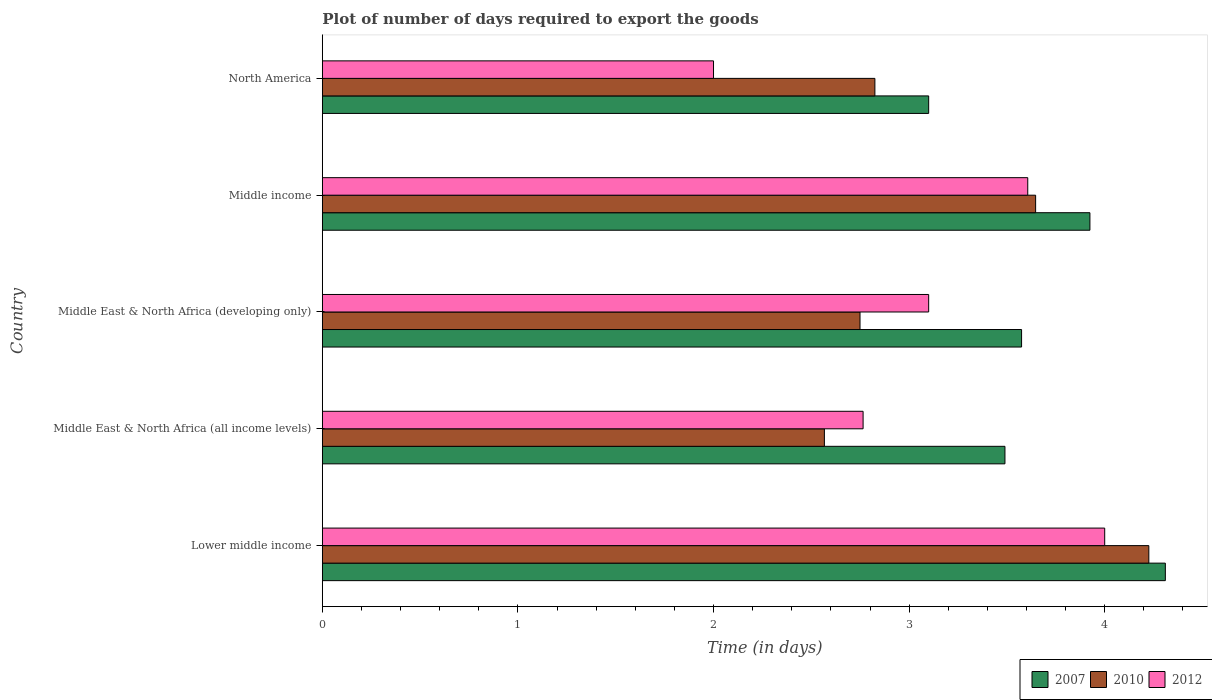How many groups of bars are there?
Keep it short and to the point. 5. Are the number of bars on each tick of the Y-axis equal?
Your answer should be compact. Yes. How many bars are there on the 4th tick from the top?
Provide a short and direct response. 3. How many bars are there on the 5th tick from the bottom?
Provide a succinct answer. 3. What is the label of the 5th group of bars from the top?
Your answer should be very brief. Lower middle income. In how many cases, is the number of bars for a given country not equal to the number of legend labels?
Provide a short and direct response. 0. What is the time required to export goods in 2007 in Middle East & North Africa (all income levels)?
Provide a short and direct response. 3.49. Across all countries, what is the maximum time required to export goods in 2010?
Your answer should be very brief. 4.23. In which country was the time required to export goods in 2012 maximum?
Ensure brevity in your answer.  Lower middle income. In which country was the time required to export goods in 2007 minimum?
Ensure brevity in your answer.  North America. What is the total time required to export goods in 2007 in the graph?
Provide a short and direct response. 18.4. What is the difference between the time required to export goods in 2007 in Middle East & North Africa (developing only) and that in Middle income?
Provide a succinct answer. -0.35. What is the difference between the time required to export goods in 2007 in Lower middle income and the time required to export goods in 2010 in Middle East & North Africa (developing only)?
Provide a succinct answer. 1.56. What is the average time required to export goods in 2007 per country?
Offer a terse response. 3.68. What is the difference between the time required to export goods in 2010 and time required to export goods in 2012 in North America?
Your answer should be compact. 0.83. What is the ratio of the time required to export goods in 2012 in Middle East & North Africa (developing only) to that in North America?
Offer a terse response. 1.55. What is the difference between the highest and the second highest time required to export goods in 2012?
Make the answer very short. 0.39. What is the difference between the highest and the lowest time required to export goods in 2007?
Your response must be concise. 1.21. What does the 3rd bar from the bottom in Middle income represents?
Provide a short and direct response. 2012. How many countries are there in the graph?
Ensure brevity in your answer.  5. How many legend labels are there?
Ensure brevity in your answer.  3. What is the title of the graph?
Offer a very short reply. Plot of number of days required to export the goods. What is the label or title of the X-axis?
Your answer should be very brief. Time (in days). What is the label or title of the Y-axis?
Your response must be concise. Country. What is the Time (in days) of 2007 in Lower middle income?
Offer a very short reply. 4.31. What is the Time (in days) in 2010 in Lower middle income?
Your answer should be compact. 4.23. What is the Time (in days) of 2012 in Lower middle income?
Your answer should be very brief. 4. What is the Time (in days) of 2007 in Middle East & North Africa (all income levels)?
Provide a succinct answer. 3.49. What is the Time (in days) in 2010 in Middle East & North Africa (all income levels)?
Keep it short and to the point. 2.57. What is the Time (in days) of 2012 in Middle East & North Africa (all income levels)?
Your answer should be very brief. 2.76. What is the Time (in days) of 2007 in Middle East & North Africa (developing only)?
Give a very brief answer. 3.58. What is the Time (in days) of 2010 in Middle East & North Africa (developing only)?
Make the answer very short. 2.75. What is the Time (in days) in 2012 in Middle East & North Africa (developing only)?
Offer a very short reply. 3.1. What is the Time (in days) of 2007 in Middle income?
Your response must be concise. 3.92. What is the Time (in days) in 2010 in Middle income?
Ensure brevity in your answer.  3.65. What is the Time (in days) in 2012 in Middle income?
Offer a very short reply. 3.61. What is the Time (in days) in 2007 in North America?
Provide a short and direct response. 3.1. What is the Time (in days) of 2010 in North America?
Your response must be concise. 2.83. Across all countries, what is the maximum Time (in days) in 2007?
Offer a terse response. 4.31. Across all countries, what is the maximum Time (in days) in 2010?
Offer a terse response. 4.23. Across all countries, what is the maximum Time (in days) of 2012?
Provide a short and direct response. 4. Across all countries, what is the minimum Time (in days) of 2010?
Provide a succinct answer. 2.57. What is the total Time (in days) in 2007 in the graph?
Provide a succinct answer. 18.4. What is the total Time (in days) of 2010 in the graph?
Provide a short and direct response. 16.01. What is the total Time (in days) of 2012 in the graph?
Provide a succinct answer. 15.47. What is the difference between the Time (in days) in 2007 in Lower middle income and that in Middle East & North Africa (all income levels)?
Your answer should be compact. 0.82. What is the difference between the Time (in days) of 2010 in Lower middle income and that in Middle East & North Africa (all income levels)?
Offer a very short reply. 1.66. What is the difference between the Time (in days) of 2012 in Lower middle income and that in Middle East & North Africa (all income levels)?
Your answer should be compact. 1.24. What is the difference between the Time (in days) of 2007 in Lower middle income and that in Middle East & North Africa (developing only)?
Your answer should be very brief. 0.73. What is the difference between the Time (in days) in 2010 in Lower middle income and that in Middle East & North Africa (developing only)?
Ensure brevity in your answer.  1.48. What is the difference between the Time (in days) of 2007 in Lower middle income and that in Middle income?
Provide a short and direct response. 0.39. What is the difference between the Time (in days) of 2010 in Lower middle income and that in Middle income?
Provide a succinct answer. 0.58. What is the difference between the Time (in days) in 2012 in Lower middle income and that in Middle income?
Offer a terse response. 0.39. What is the difference between the Time (in days) in 2007 in Lower middle income and that in North America?
Offer a terse response. 1.21. What is the difference between the Time (in days) of 2010 in Lower middle income and that in North America?
Your answer should be compact. 1.4. What is the difference between the Time (in days) in 2007 in Middle East & North Africa (all income levels) and that in Middle East & North Africa (developing only)?
Make the answer very short. -0.09. What is the difference between the Time (in days) in 2010 in Middle East & North Africa (all income levels) and that in Middle East & North Africa (developing only)?
Offer a terse response. -0.18. What is the difference between the Time (in days) in 2012 in Middle East & North Africa (all income levels) and that in Middle East & North Africa (developing only)?
Ensure brevity in your answer.  -0.34. What is the difference between the Time (in days) in 2007 in Middle East & North Africa (all income levels) and that in Middle income?
Provide a succinct answer. -0.43. What is the difference between the Time (in days) of 2010 in Middle East & North Africa (all income levels) and that in Middle income?
Keep it short and to the point. -1.08. What is the difference between the Time (in days) in 2012 in Middle East & North Africa (all income levels) and that in Middle income?
Make the answer very short. -0.84. What is the difference between the Time (in days) of 2007 in Middle East & North Africa (all income levels) and that in North America?
Offer a terse response. 0.39. What is the difference between the Time (in days) of 2010 in Middle East & North Africa (all income levels) and that in North America?
Ensure brevity in your answer.  -0.26. What is the difference between the Time (in days) of 2012 in Middle East & North Africa (all income levels) and that in North America?
Provide a succinct answer. 0.76. What is the difference between the Time (in days) in 2007 in Middle East & North Africa (developing only) and that in Middle income?
Give a very brief answer. -0.35. What is the difference between the Time (in days) in 2010 in Middle East & North Africa (developing only) and that in Middle income?
Give a very brief answer. -0.9. What is the difference between the Time (in days) of 2012 in Middle East & North Africa (developing only) and that in Middle income?
Keep it short and to the point. -0.51. What is the difference between the Time (in days) of 2007 in Middle East & North Africa (developing only) and that in North America?
Provide a succinct answer. 0.47. What is the difference between the Time (in days) of 2010 in Middle East & North Africa (developing only) and that in North America?
Your answer should be very brief. -0.08. What is the difference between the Time (in days) in 2007 in Middle income and that in North America?
Provide a short and direct response. 0.82. What is the difference between the Time (in days) in 2010 in Middle income and that in North America?
Offer a terse response. 0.82. What is the difference between the Time (in days) in 2012 in Middle income and that in North America?
Provide a short and direct response. 1.61. What is the difference between the Time (in days) of 2007 in Lower middle income and the Time (in days) of 2010 in Middle East & North Africa (all income levels)?
Ensure brevity in your answer.  1.74. What is the difference between the Time (in days) in 2007 in Lower middle income and the Time (in days) in 2012 in Middle East & North Africa (all income levels)?
Give a very brief answer. 1.55. What is the difference between the Time (in days) of 2010 in Lower middle income and the Time (in days) of 2012 in Middle East & North Africa (all income levels)?
Offer a terse response. 1.46. What is the difference between the Time (in days) in 2007 in Lower middle income and the Time (in days) in 2010 in Middle East & North Africa (developing only)?
Give a very brief answer. 1.56. What is the difference between the Time (in days) in 2007 in Lower middle income and the Time (in days) in 2012 in Middle East & North Africa (developing only)?
Offer a very short reply. 1.21. What is the difference between the Time (in days) in 2010 in Lower middle income and the Time (in days) in 2012 in Middle East & North Africa (developing only)?
Offer a very short reply. 1.13. What is the difference between the Time (in days) in 2007 in Lower middle income and the Time (in days) in 2010 in Middle income?
Your response must be concise. 0.66. What is the difference between the Time (in days) in 2007 in Lower middle income and the Time (in days) in 2012 in Middle income?
Your answer should be compact. 0.7. What is the difference between the Time (in days) of 2010 in Lower middle income and the Time (in days) of 2012 in Middle income?
Offer a very short reply. 0.62. What is the difference between the Time (in days) in 2007 in Lower middle income and the Time (in days) in 2010 in North America?
Your answer should be compact. 1.49. What is the difference between the Time (in days) in 2007 in Lower middle income and the Time (in days) in 2012 in North America?
Provide a succinct answer. 2.31. What is the difference between the Time (in days) in 2010 in Lower middle income and the Time (in days) in 2012 in North America?
Give a very brief answer. 2.23. What is the difference between the Time (in days) in 2007 in Middle East & North Africa (all income levels) and the Time (in days) in 2010 in Middle East & North Africa (developing only)?
Provide a succinct answer. 0.74. What is the difference between the Time (in days) of 2007 in Middle East & North Africa (all income levels) and the Time (in days) of 2012 in Middle East & North Africa (developing only)?
Offer a terse response. 0.39. What is the difference between the Time (in days) of 2010 in Middle East & North Africa (all income levels) and the Time (in days) of 2012 in Middle East & North Africa (developing only)?
Make the answer very short. -0.53. What is the difference between the Time (in days) of 2007 in Middle East & North Africa (all income levels) and the Time (in days) of 2010 in Middle income?
Offer a very short reply. -0.16. What is the difference between the Time (in days) in 2007 in Middle East & North Africa (all income levels) and the Time (in days) in 2012 in Middle income?
Offer a very short reply. -0.12. What is the difference between the Time (in days) in 2010 in Middle East & North Africa (all income levels) and the Time (in days) in 2012 in Middle income?
Ensure brevity in your answer.  -1.04. What is the difference between the Time (in days) of 2007 in Middle East & North Africa (all income levels) and the Time (in days) of 2010 in North America?
Offer a very short reply. 0.67. What is the difference between the Time (in days) of 2007 in Middle East & North Africa (all income levels) and the Time (in days) of 2012 in North America?
Keep it short and to the point. 1.49. What is the difference between the Time (in days) of 2010 in Middle East & North Africa (all income levels) and the Time (in days) of 2012 in North America?
Your response must be concise. 0.57. What is the difference between the Time (in days) of 2007 in Middle East & North Africa (developing only) and the Time (in days) of 2010 in Middle income?
Keep it short and to the point. -0.07. What is the difference between the Time (in days) of 2007 in Middle East & North Africa (developing only) and the Time (in days) of 2012 in Middle income?
Keep it short and to the point. -0.03. What is the difference between the Time (in days) of 2010 in Middle East & North Africa (developing only) and the Time (in days) of 2012 in Middle income?
Offer a very short reply. -0.86. What is the difference between the Time (in days) of 2007 in Middle East & North Africa (developing only) and the Time (in days) of 2012 in North America?
Keep it short and to the point. 1.57. What is the difference between the Time (in days) in 2010 in Middle East & North Africa (developing only) and the Time (in days) in 2012 in North America?
Make the answer very short. 0.75. What is the difference between the Time (in days) in 2007 in Middle income and the Time (in days) in 2010 in North America?
Provide a succinct answer. 1.1. What is the difference between the Time (in days) in 2007 in Middle income and the Time (in days) in 2012 in North America?
Offer a very short reply. 1.92. What is the difference between the Time (in days) in 2010 in Middle income and the Time (in days) in 2012 in North America?
Offer a very short reply. 1.65. What is the average Time (in days) of 2007 per country?
Offer a terse response. 3.68. What is the average Time (in days) of 2010 per country?
Ensure brevity in your answer.  3.2. What is the average Time (in days) of 2012 per country?
Your answer should be compact. 3.09. What is the difference between the Time (in days) of 2007 and Time (in days) of 2010 in Lower middle income?
Offer a terse response. 0.08. What is the difference between the Time (in days) of 2007 and Time (in days) of 2012 in Lower middle income?
Offer a terse response. 0.31. What is the difference between the Time (in days) in 2010 and Time (in days) in 2012 in Lower middle income?
Ensure brevity in your answer.  0.23. What is the difference between the Time (in days) of 2007 and Time (in days) of 2010 in Middle East & North Africa (all income levels)?
Offer a very short reply. 0.92. What is the difference between the Time (in days) in 2007 and Time (in days) in 2012 in Middle East & North Africa (all income levels)?
Give a very brief answer. 0.73. What is the difference between the Time (in days) of 2010 and Time (in days) of 2012 in Middle East & North Africa (all income levels)?
Provide a short and direct response. -0.2. What is the difference between the Time (in days) of 2007 and Time (in days) of 2010 in Middle East & North Africa (developing only)?
Provide a short and direct response. 0.83. What is the difference between the Time (in days) of 2007 and Time (in days) of 2012 in Middle East & North Africa (developing only)?
Give a very brief answer. 0.47. What is the difference between the Time (in days) in 2010 and Time (in days) in 2012 in Middle East & North Africa (developing only)?
Your answer should be compact. -0.35. What is the difference between the Time (in days) in 2007 and Time (in days) in 2010 in Middle income?
Ensure brevity in your answer.  0.28. What is the difference between the Time (in days) of 2007 and Time (in days) of 2012 in Middle income?
Your answer should be compact. 0.32. What is the difference between the Time (in days) of 2010 and Time (in days) of 2012 in Middle income?
Ensure brevity in your answer.  0.04. What is the difference between the Time (in days) in 2007 and Time (in days) in 2010 in North America?
Offer a terse response. 0.28. What is the difference between the Time (in days) of 2010 and Time (in days) of 2012 in North America?
Offer a very short reply. 0.82. What is the ratio of the Time (in days) of 2007 in Lower middle income to that in Middle East & North Africa (all income levels)?
Offer a terse response. 1.24. What is the ratio of the Time (in days) of 2010 in Lower middle income to that in Middle East & North Africa (all income levels)?
Make the answer very short. 1.65. What is the ratio of the Time (in days) of 2012 in Lower middle income to that in Middle East & North Africa (all income levels)?
Keep it short and to the point. 1.45. What is the ratio of the Time (in days) of 2007 in Lower middle income to that in Middle East & North Africa (developing only)?
Your answer should be very brief. 1.21. What is the ratio of the Time (in days) of 2010 in Lower middle income to that in Middle East & North Africa (developing only)?
Provide a succinct answer. 1.54. What is the ratio of the Time (in days) of 2012 in Lower middle income to that in Middle East & North Africa (developing only)?
Your answer should be very brief. 1.29. What is the ratio of the Time (in days) in 2007 in Lower middle income to that in Middle income?
Offer a very short reply. 1.1. What is the ratio of the Time (in days) of 2010 in Lower middle income to that in Middle income?
Your answer should be very brief. 1.16. What is the ratio of the Time (in days) of 2012 in Lower middle income to that in Middle income?
Ensure brevity in your answer.  1.11. What is the ratio of the Time (in days) of 2007 in Lower middle income to that in North America?
Offer a very short reply. 1.39. What is the ratio of the Time (in days) of 2010 in Lower middle income to that in North America?
Offer a terse response. 1.5. What is the ratio of the Time (in days) of 2007 in Middle East & North Africa (all income levels) to that in Middle East & North Africa (developing only)?
Your answer should be compact. 0.98. What is the ratio of the Time (in days) in 2010 in Middle East & North Africa (all income levels) to that in Middle East & North Africa (developing only)?
Your answer should be very brief. 0.93. What is the ratio of the Time (in days) of 2012 in Middle East & North Africa (all income levels) to that in Middle East & North Africa (developing only)?
Your answer should be compact. 0.89. What is the ratio of the Time (in days) of 2007 in Middle East & North Africa (all income levels) to that in Middle income?
Make the answer very short. 0.89. What is the ratio of the Time (in days) of 2010 in Middle East & North Africa (all income levels) to that in Middle income?
Offer a very short reply. 0.7. What is the ratio of the Time (in days) of 2012 in Middle East & North Africa (all income levels) to that in Middle income?
Your answer should be compact. 0.77. What is the ratio of the Time (in days) of 2007 in Middle East & North Africa (all income levels) to that in North America?
Offer a terse response. 1.13. What is the ratio of the Time (in days) of 2010 in Middle East & North Africa (all income levels) to that in North America?
Your answer should be compact. 0.91. What is the ratio of the Time (in days) in 2012 in Middle East & North Africa (all income levels) to that in North America?
Make the answer very short. 1.38. What is the ratio of the Time (in days) in 2007 in Middle East & North Africa (developing only) to that in Middle income?
Your answer should be compact. 0.91. What is the ratio of the Time (in days) in 2010 in Middle East & North Africa (developing only) to that in Middle income?
Offer a terse response. 0.75. What is the ratio of the Time (in days) of 2012 in Middle East & North Africa (developing only) to that in Middle income?
Make the answer very short. 0.86. What is the ratio of the Time (in days) in 2007 in Middle East & North Africa (developing only) to that in North America?
Provide a succinct answer. 1.15. What is the ratio of the Time (in days) in 2010 in Middle East & North Africa (developing only) to that in North America?
Provide a short and direct response. 0.97. What is the ratio of the Time (in days) of 2012 in Middle East & North Africa (developing only) to that in North America?
Keep it short and to the point. 1.55. What is the ratio of the Time (in days) of 2007 in Middle income to that in North America?
Your response must be concise. 1.27. What is the ratio of the Time (in days) of 2010 in Middle income to that in North America?
Your answer should be compact. 1.29. What is the ratio of the Time (in days) of 2012 in Middle income to that in North America?
Give a very brief answer. 1.8. What is the difference between the highest and the second highest Time (in days) in 2007?
Your answer should be very brief. 0.39. What is the difference between the highest and the second highest Time (in days) of 2010?
Offer a terse response. 0.58. What is the difference between the highest and the second highest Time (in days) in 2012?
Your answer should be very brief. 0.39. What is the difference between the highest and the lowest Time (in days) in 2007?
Provide a succinct answer. 1.21. What is the difference between the highest and the lowest Time (in days) of 2010?
Ensure brevity in your answer.  1.66. What is the difference between the highest and the lowest Time (in days) in 2012?
Your answer should be compact. 2. 